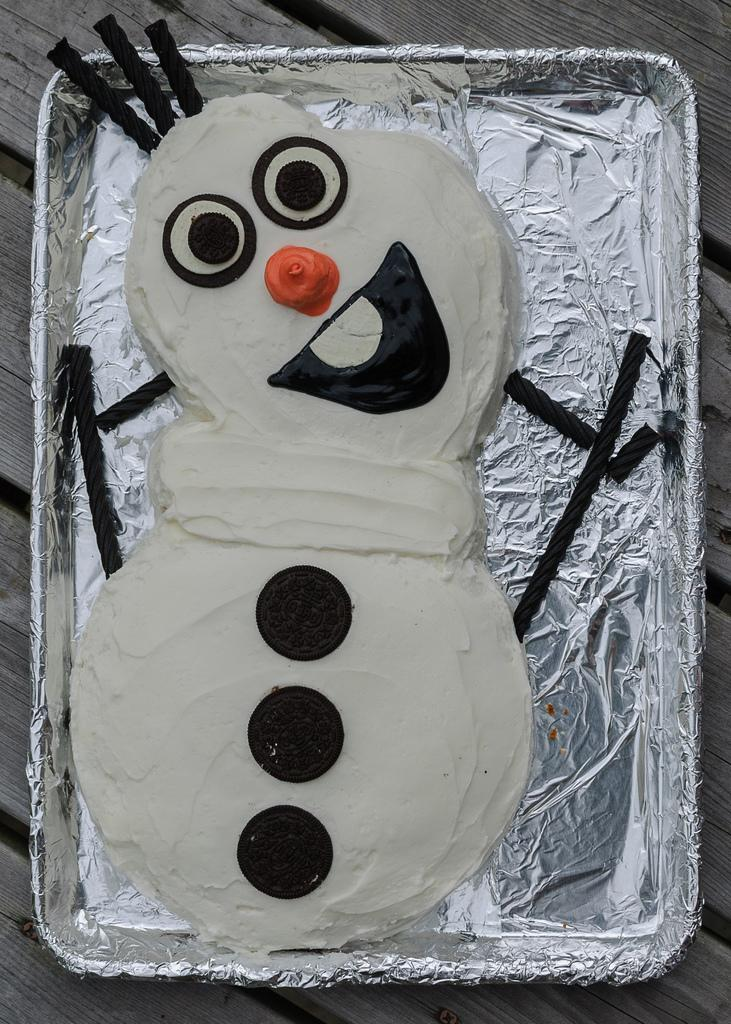What type of table is in the image? There is a wooden table in the image. What is on top of the wooden table? There is a tray on the table. What is inside the tray? There is a food item in the tray. What type of experience can be gained from the grain in the image? There is no grain present in the image, so it is not possible to gain any experience from it. 